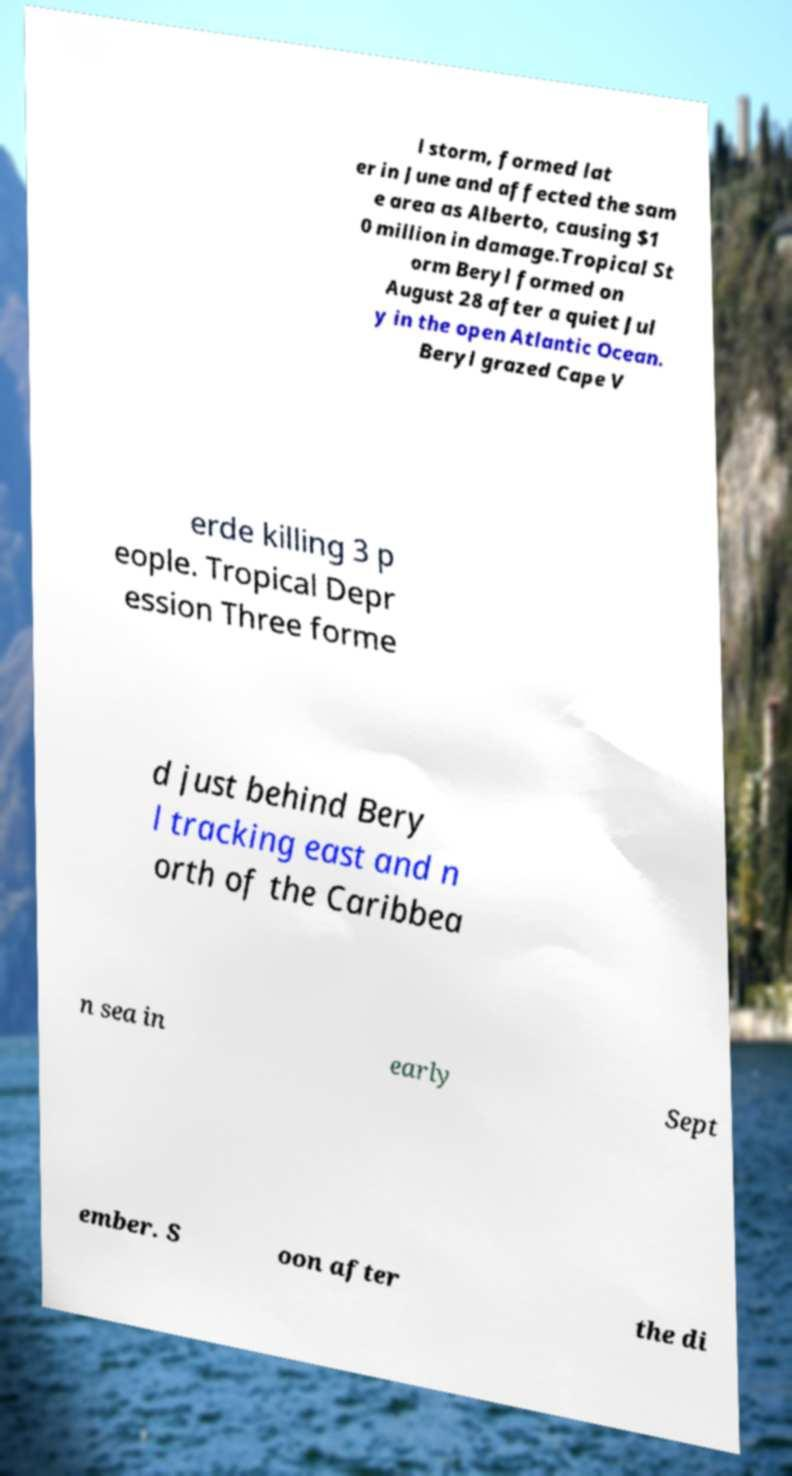For documentation purposes, I need the text within this image transcribed. Could you provide that? l storm, formed lat er in June and affected the sam e area as Alberto, causing $1 0 million in damage.Tropical St orm Beryl formed on August 28 after a quiet Jul y in the open Atlantic Ocean. Beryl grazed Cape V erde killing 3 p eople. Tropical Depr ession Three forme d just behind Bery l tracking east and n orth of the Caribbea n sea in early Sept ember. S oon after the di 